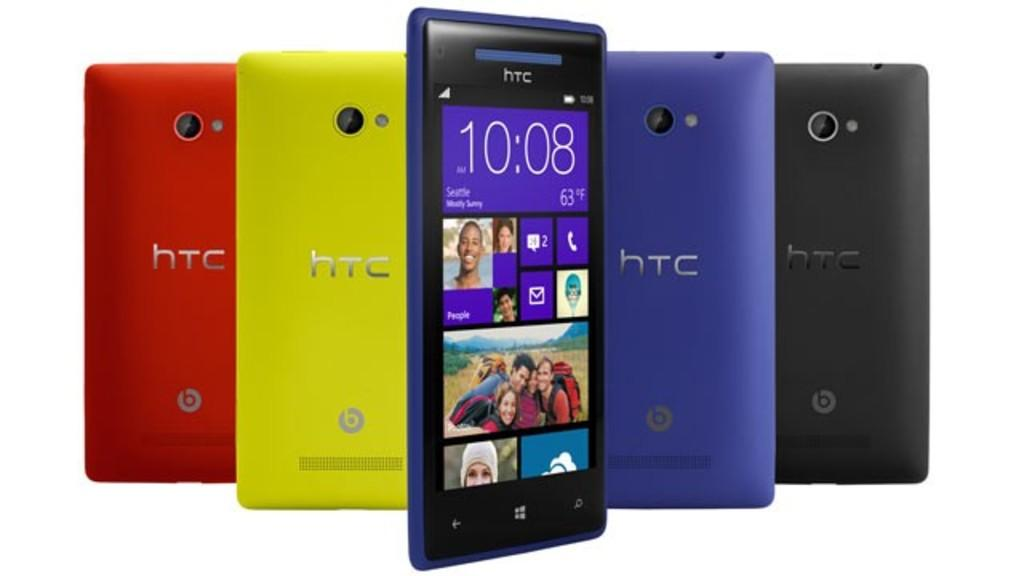<image>
Offer a succinct explanation of the picture presented. Five cellphones from the brand HTC, each a different color. 